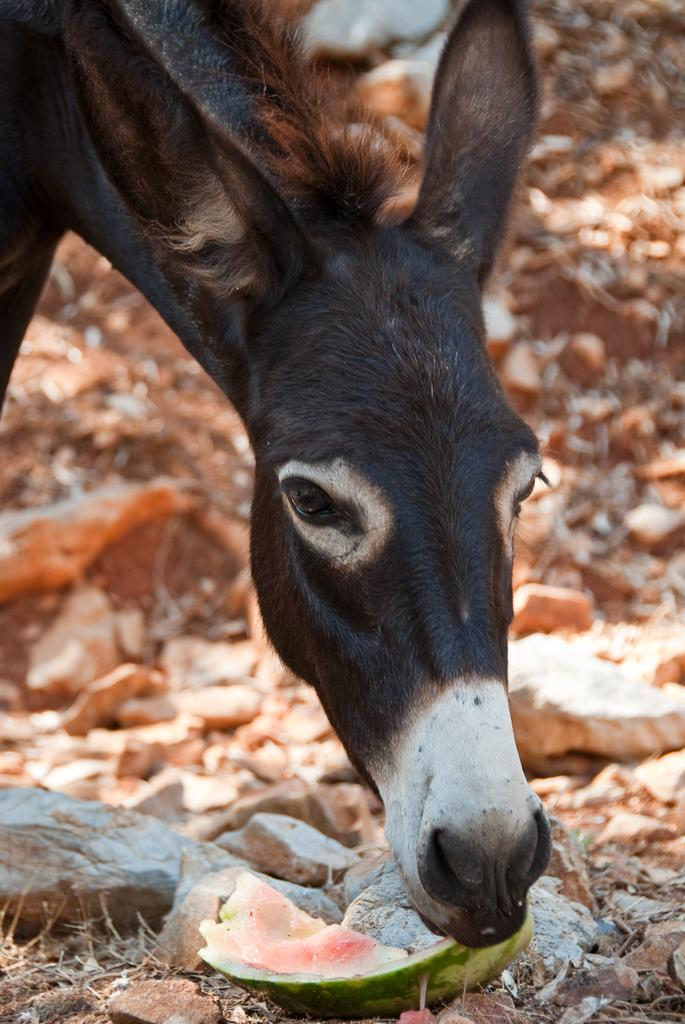What animal can be seen in the picture? There is a donkey in the picture. What is the donkey doing in the picture? The donkey is eating a watermelon. What other objects are present in the picture? There are stones and dry leaves in the picture. What caption is written on the watermelon in the picture? There is no caption written on the watermelon in the picture. What direction is the grandfather facing in the picture? There is no grandfather present in the picture. 